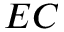Convert formula to latex. <formula><loc_0><loc_0><loc_500><loc_500>E C</formula> 